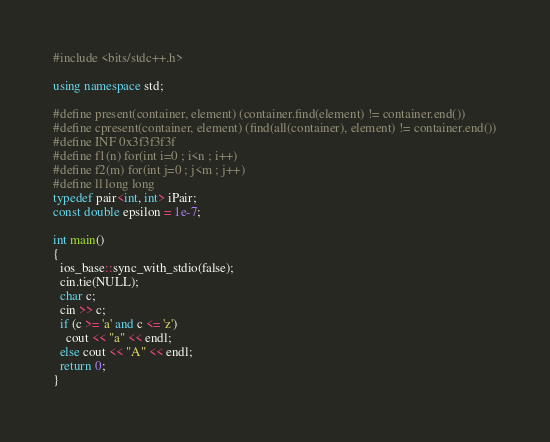<code> <loc_0><loc_0><loc_500><loc_500><_C++_>#include <bits/stdc++.h>

using namespace std;

#define present(container, element) (container.find(element) != container.end())
#define cpresent(container, element) (find(all(container), element) != container.end())
#define INF 0x3f3f3f3f
#define f1(n) for(int i=0 ; i<n ; i++)
#define f2(m) for(int j=0 ; j<m ; j++)
#define ll long long
typedef pair<int, int> iPair;
const double epsilon = 1e-7;

int main()
{
  ios_base::sync_with_stdio(false);
  cin.tie(NULL);
  char c;
  cin >> c;
  if (c >= 'a' and c <= 'z')
    cout << "a" << endl;
  else cout << "A" << endl;
  return 0;
}</code> 